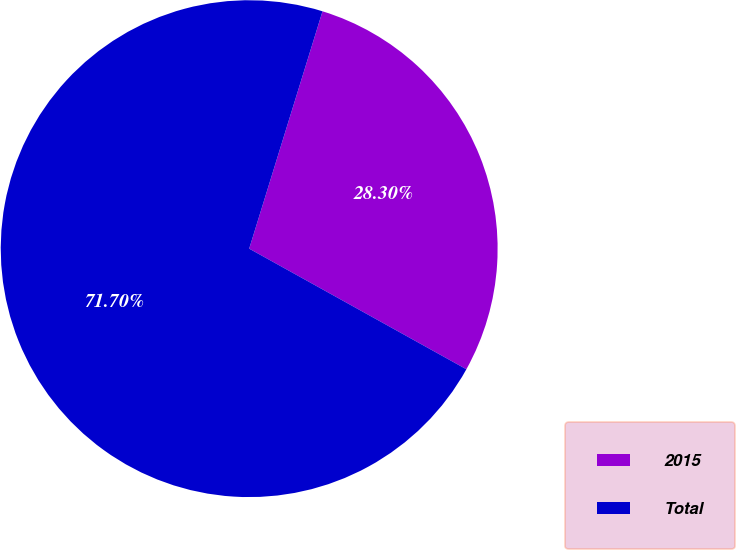Convert chart to OTSL. <chart><loc_0><loc_0><loc_500><loc_500><pie_chart><fcel>2015<fcel>Total<nl><fcel>28.3%<fcel>71.7%<nl></chart> 